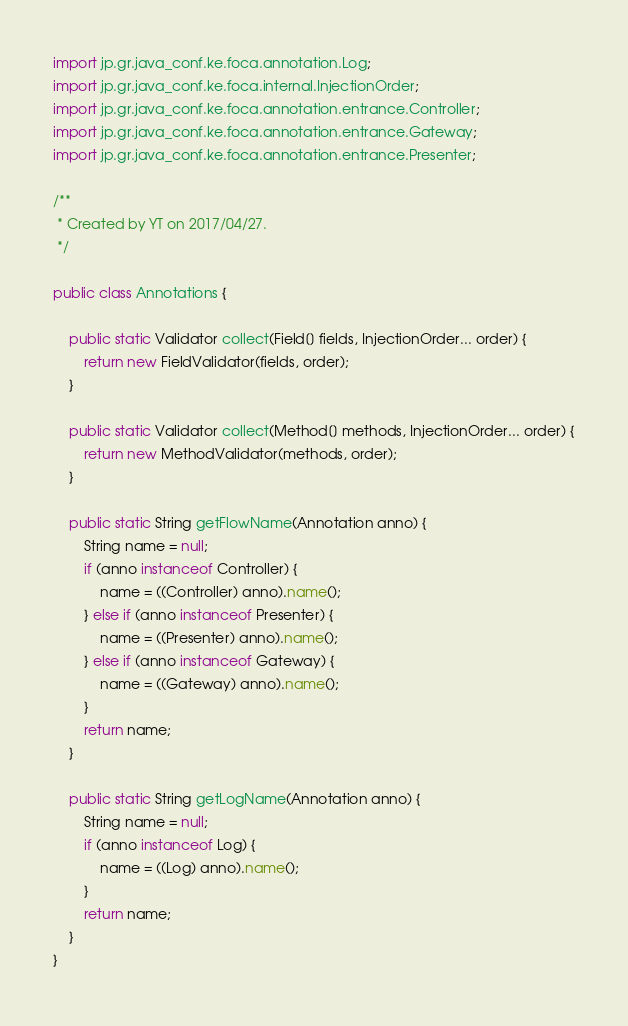Convert code to text. <code><loc_0><loc_0><loc_500><loc_500><_Java_>
import jp.gr.java_conf.ke.foca.annotation.Log;
import jp.gr.java_conf.ke.foca.internal.InjectionOrder;
import jp.gr.java_conf.ke.foca.annotation.entrance.Controller;
import jp.gr.java_conf.ke.foca.annotation.entrance.Gateway;
import jp.gr.java_conf.ke.foca.annotation.entrance.Presenter;

/**
 * Created by YT on 2017/04/27.
 */

public class Annotations {

    public static Validator collect(Field[] fields, InjectionOrder... order) {
        return new FieldValidator(fields, order);
    }

    public static Validator collect(Method[] methods, InjectionOrder... order) {
        return new MethodValidator(methods, order);
    }

    public static String getFlowName(Annotation anno) {
        String name = null;
        if (anno instanceof Controller) {
            name = ((Controller) anno).name();
        } else if (anno instanceof Presenter) {
            name = ((Presenter) anno).name();
        } else if (anno instanceof Gateway) {
            name = ((Gateway) anno).name();
        }
        return name;
    }

    public static String getLogName(Annotation anno) {
        String name = null;
        if (anno instanceof Log) {
            name = ((Log) anno).name();
        }
        return name;
    }
}
</code> 